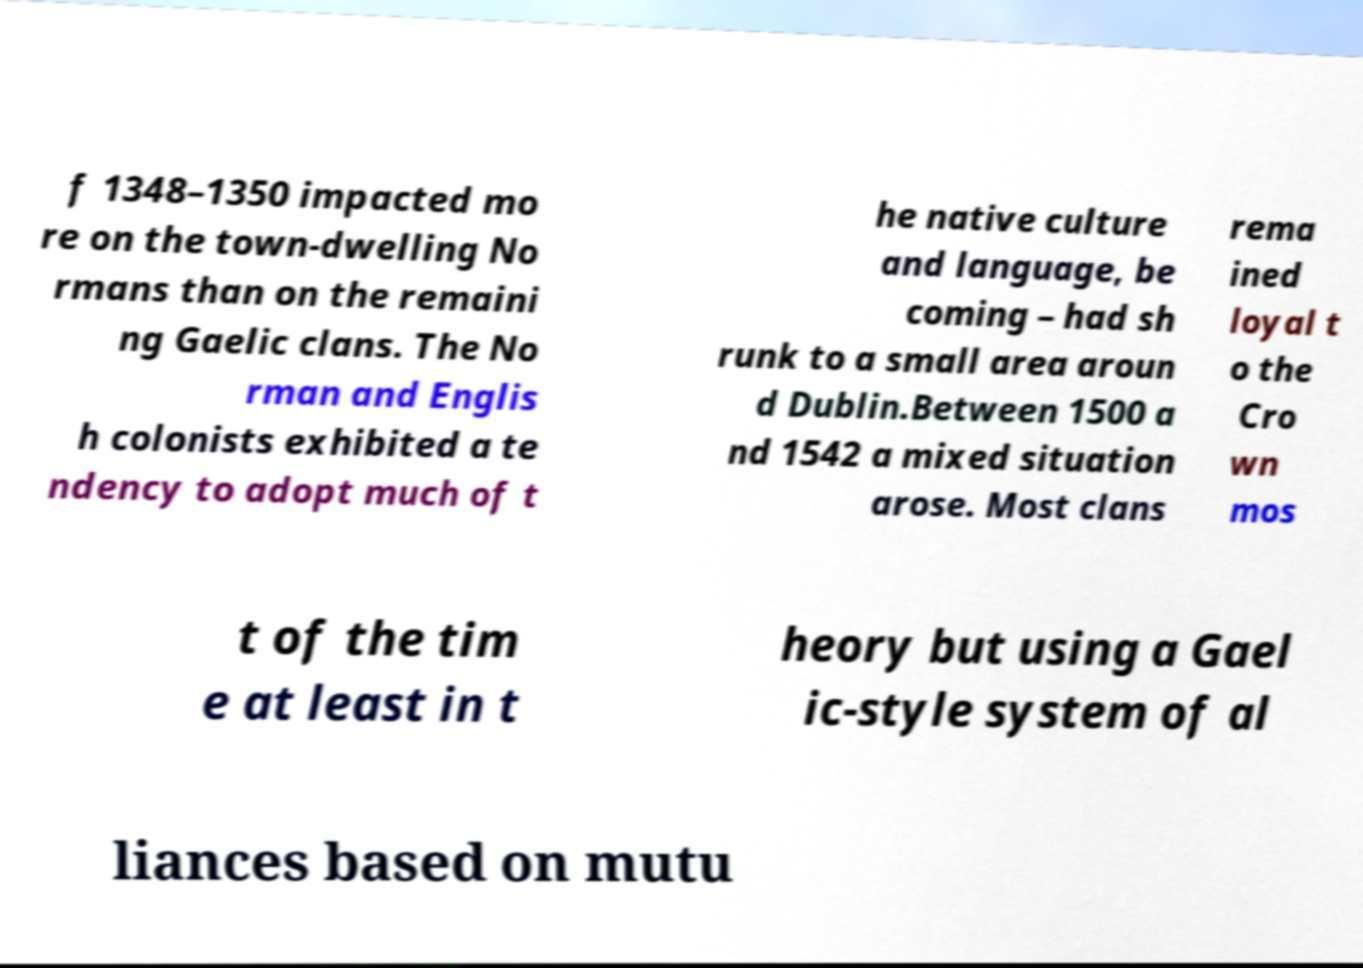Can you read and provide the text displayed in the image?This photo seems to have some interesting text. Can you extract and type it out for me? f 1348–1350 impacted mo re on the town-dwelling No rmans than on the remaini ng Gaelic clans. The No rman and Englis h colonists exhibited a te ndency to adopt much of t he native culture and language, be coming – had sh runk to a small area aroun d Dublin.Between 1500 a nd 1542 a mixed situation arose. Most clans rema ined loyal t o the Cro wn mos t of the tim e at least in t heory but using a Gael ic-style system of al liances based on mutu 